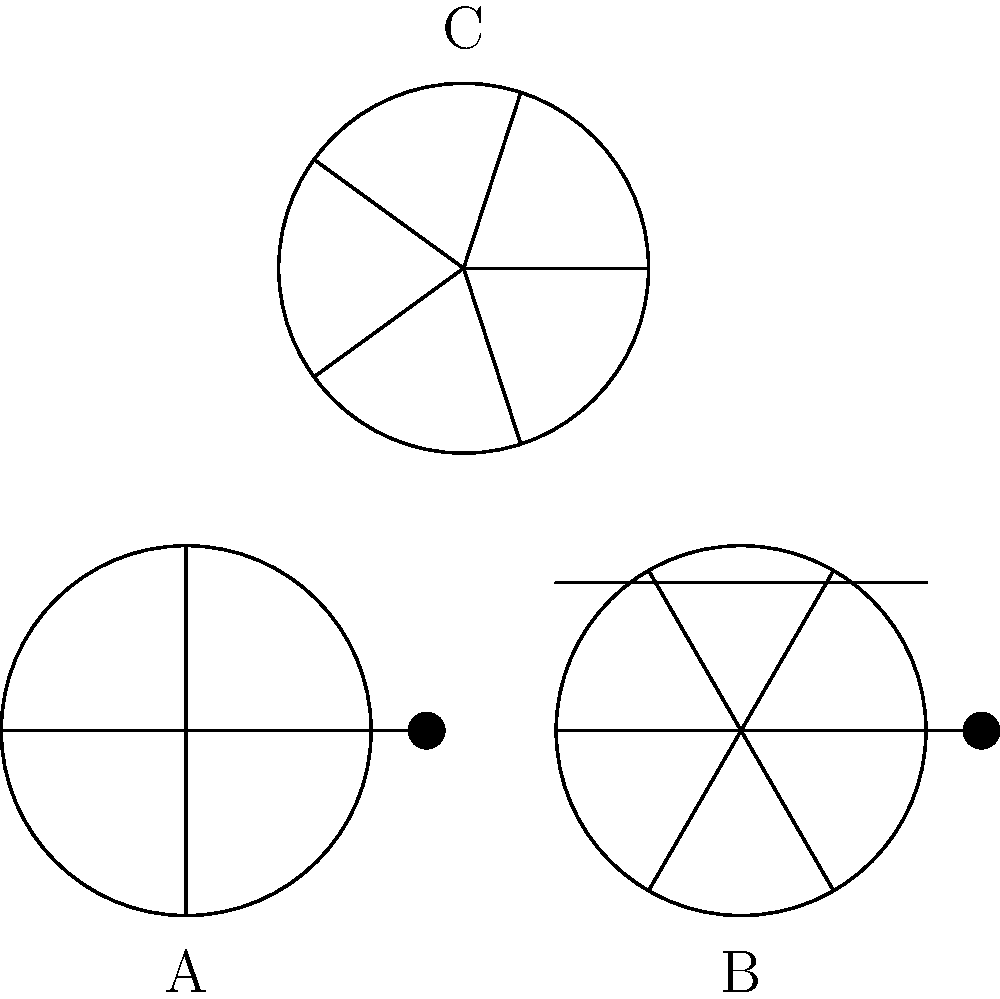Based on the visual features shown in the diagram, which of the vintage fishing reels (A, B, or C) is most likely to be a modern baitcasting reel? To determine which reel is most likely a modern baitcasting reel, let's analyze the features of each:

1. Reel A:
   - Has 4 spokes
   - Features a crank handle
   - No visible lever drag system

2. Reel B:
   - Has 6 spokes
   - Features a crank handle
   - Has a visible lever drag system (horizontal bar above the reel)

3. Reel C:
   - Has 5 spokes
   - No visible crank handle
   - No visible lever drag system

Modern baitcasting reels typically have the following characteristics:
1. A higher number of spokes for increased strength and reduced weight
2. A crank handle for retrieving line
3. A lever drag system for precise drag adjustment

Based on these criteria, Reel B is the most likely to be a modern baitcasting reel. It has the highest number of spokes (6), a crank handle, and a visible lever drag system. These features are consistent with modern baitcasting reel design, which prioritizes precision and control for accurate casting and fish fighting.
Answer: B 